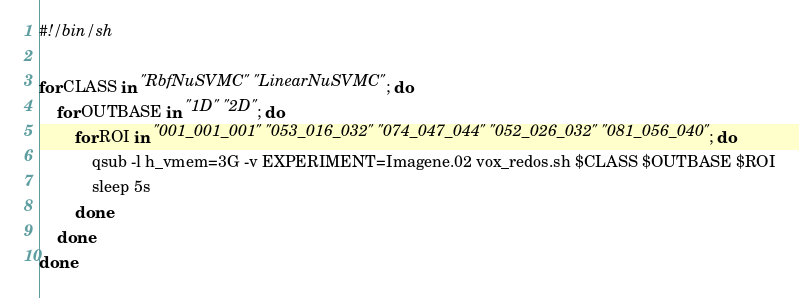<code> <loc_0><loc_0><loc_500><loc_500><_Bash_>#!/bin/sh

for CLASS in "RbfNuSVMC" "LinearNuSVMC"; do
	for OUTBASE in "1D" "2D"; do
		for ROI in "001_001_001" "053_016_032" "074_047_044" "052_026_032" "081_056_040"; do
			qsub -l h_vmem=3G -v EXPERIMENT=Imagene.02 vox_redos.sh $CLASS $OUTBASE $ROI
			sleep 5s
		done
	done
done

</code> 